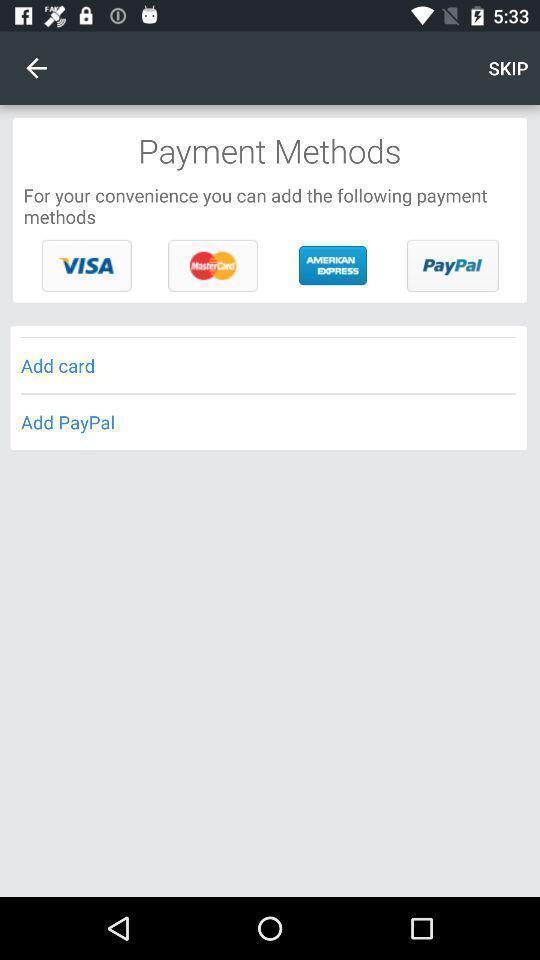Provide a description of this screenshot. Various types of payment methods in the financial transaction. 